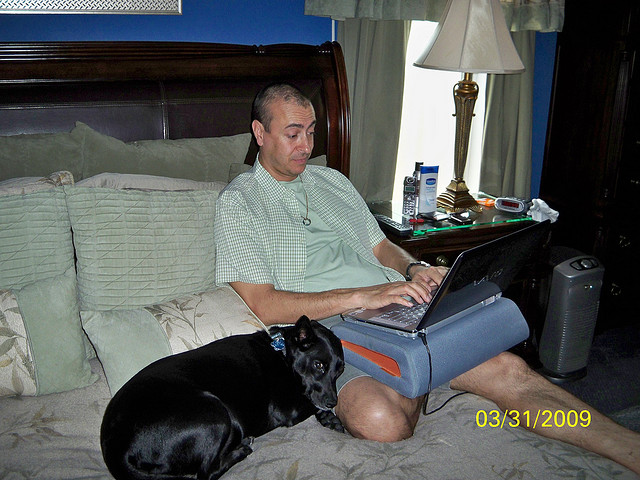Please extract the text content from this image. 03/31/2009 